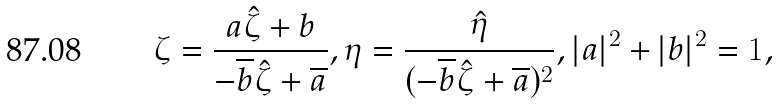<formula> <loc_0><loc_0><loc_500><loc_500>\zeta = \frac { a \hat { \zeta } + b } { - \overline { b } \hat { \zeta } + \overline { a } } , \eta = \frac { \hat { \eta } } { ( - \overline { b } \hat { \zeta } + \overline { a } ) ^ { 2 } } , | a | ^ { 2 } + | b | ^ { 2 } = 1 ,</formula> 